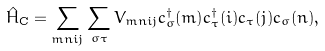Convert formula to latex. <formula><loc_0><loc_0><loc_500><loc_500>\hat { H } _ { \text {C} } = \sum _ { m n i j } \sum _ { \sigma \tau } { V } _ { m n i j } c _ { \sigma } ^ { \dagger } ( m ) c _ { \tau } ^ { \dagger } ( i ) c _ { \tau } ( j ) c _ { \sigma } ( n ) ,</formula> 